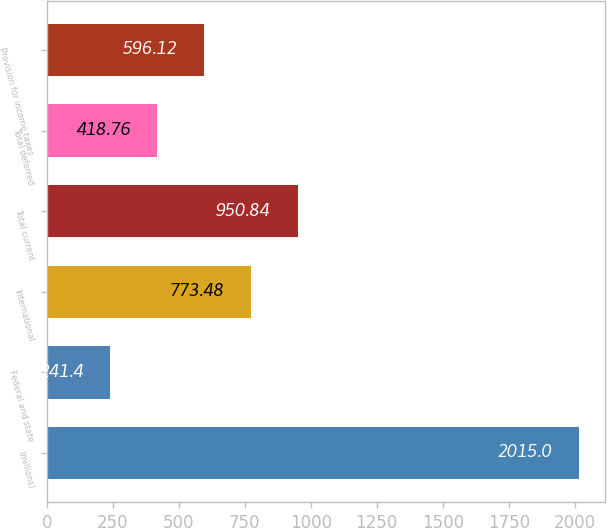Convert chart. <chart><loc_0><loc_0><loc_500><loc_500><bar_chart><fcel>(millions)<fcel>Federal and state<fcel>International<fcel>Total current<fcel>Total deferred<fcel>Provision for income taxes<nl><fcel>2015<fcel>241.4<fcel>773.48<fcel>950.84<fcel>418.76<fcel>596.12<nl></chart> 